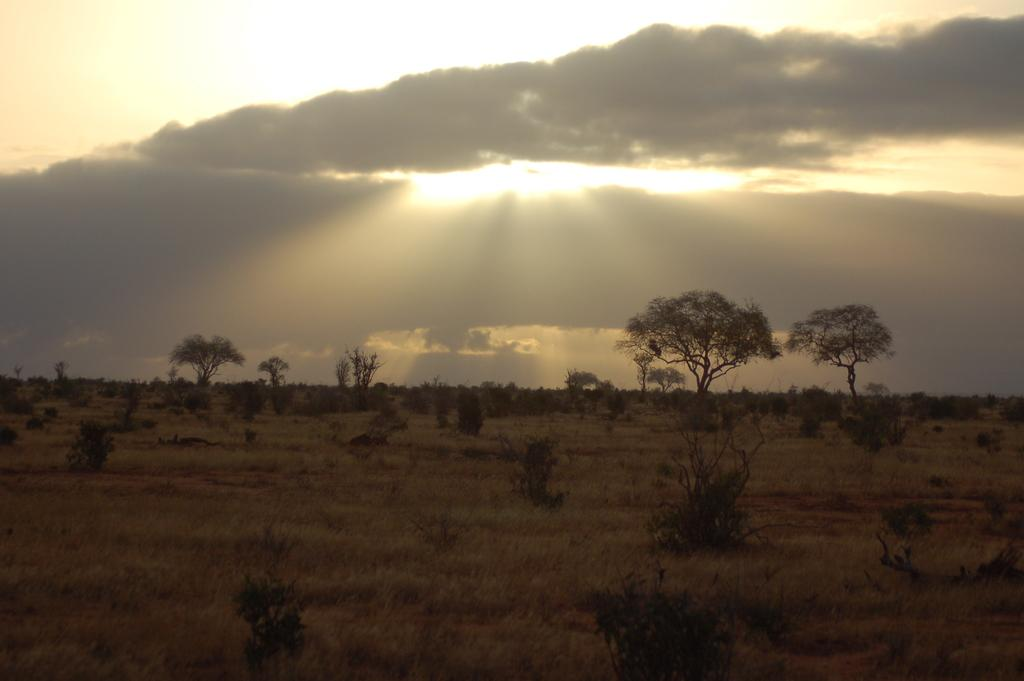What type of vegetation is present in the image? There is dry grass in the image. What else can be seen in the image besides the dry grass? There are trees in the image. What is visible at the top of the image? The sky is visible at the top of the image. What can be observed in the sky? There are clouds in the sky. Can you see a basket filled with rocks in the image? There is no basket or rocks present in the image. 